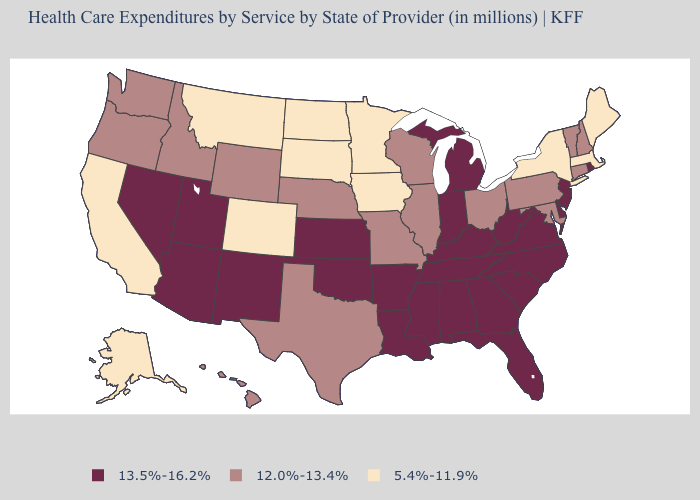Is the legend a continuous bar?
Be succinct. No. What is the lowest value in the South?
Short answer required. 12.0%-13.4%. What is the value of Delaware?
Answer briefly. 13.5%-16.2%. Name the states that have a value in the range 13.5%-16.2%?
Quick response, please. Alabama, Arizona, Arkansas, Delaware, Florida, Georgia, Indiana, Kansas, Kentucky, Louisiana, Michigan, Mississippi, Nevada, New Jersey, New Mexico, North Carolina, Oklahoma, Rhode Island, South Carolina, Tennessee, Utah, Virginia, West Virginia. Does Delaware have a higher value than South Carolina?
Keep it brief. No. Name the states that have a value in the range 12.0%-13.4%?
Give a very brief answer. Connecticut, Hawaii, Idaho, Illinois, Maryland, Missouri, Nebraska, New Hampshire, Ohio, Oregon, Pennsylvania, Texas, Vermont, Washington, Wisconsin, Wyoming. What is the lowest value in the USA?
Be succinct. 5.4%-11.9%. What is the lowest value in the USA?
Concise answer only. 5.4%-11.9%. Which states have the lowest value in the Northeast?
Short answer required. Maine, Massachusetts, New York. What is the value of Illinois?
Give a very brief answer. 12.0%-13.4%. Does Georgia have the same value as Wyoming?
Answer briefly. No. What is the lowest value in the Northeast?
Give a very brief answer. 5.4%-11.9%. What is the value of Arizona?
Give a very brief answer. 13.5%-16.2%. Name the states that have a value in the range 13.5%-16.2%?
Short answer required. Alabama, Arizona, Arkansas, Delaware, Florida, Georgia, Indiana, Kansas, Kentucky, Louisiana, Michigan, Mississippi, Nevada, New Jersey, New Mexico, North Carolina, Oklahoma, Rhode Island, South Carolina, Tennessee, Utah, Virginia, West Virginia. What is the value of Ohio?
Keep it brief. 12.0%-13.4%. 